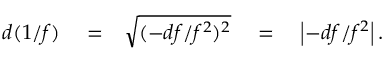<formula> <loc_0><loc_0><loc_500><loc_500>\begin{array} { r l r } { d ( 1 / f ) } & = } & { \sqrt { ( - d f / f ^ { 2 } ) ^ { 2 } } \quad = \quad \left | - d f / f ^ { 2 } \right | . } \end{array}</formula> 